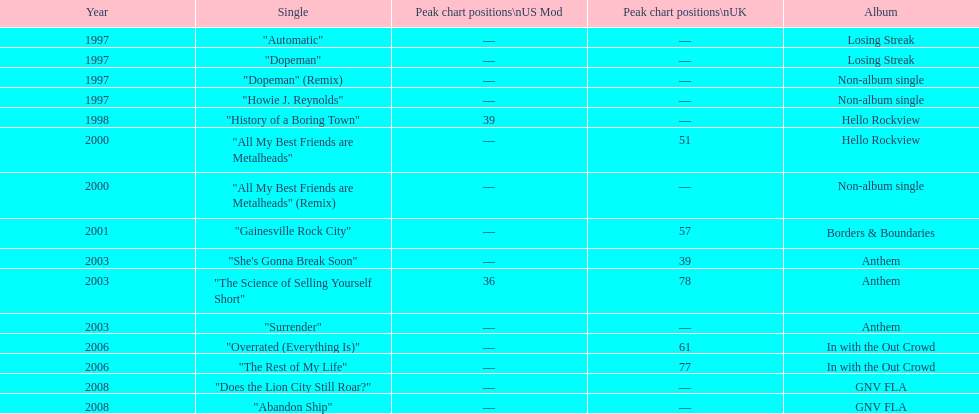Over how many years did the gap between the losing streak album and gnv fla occur? 11. 